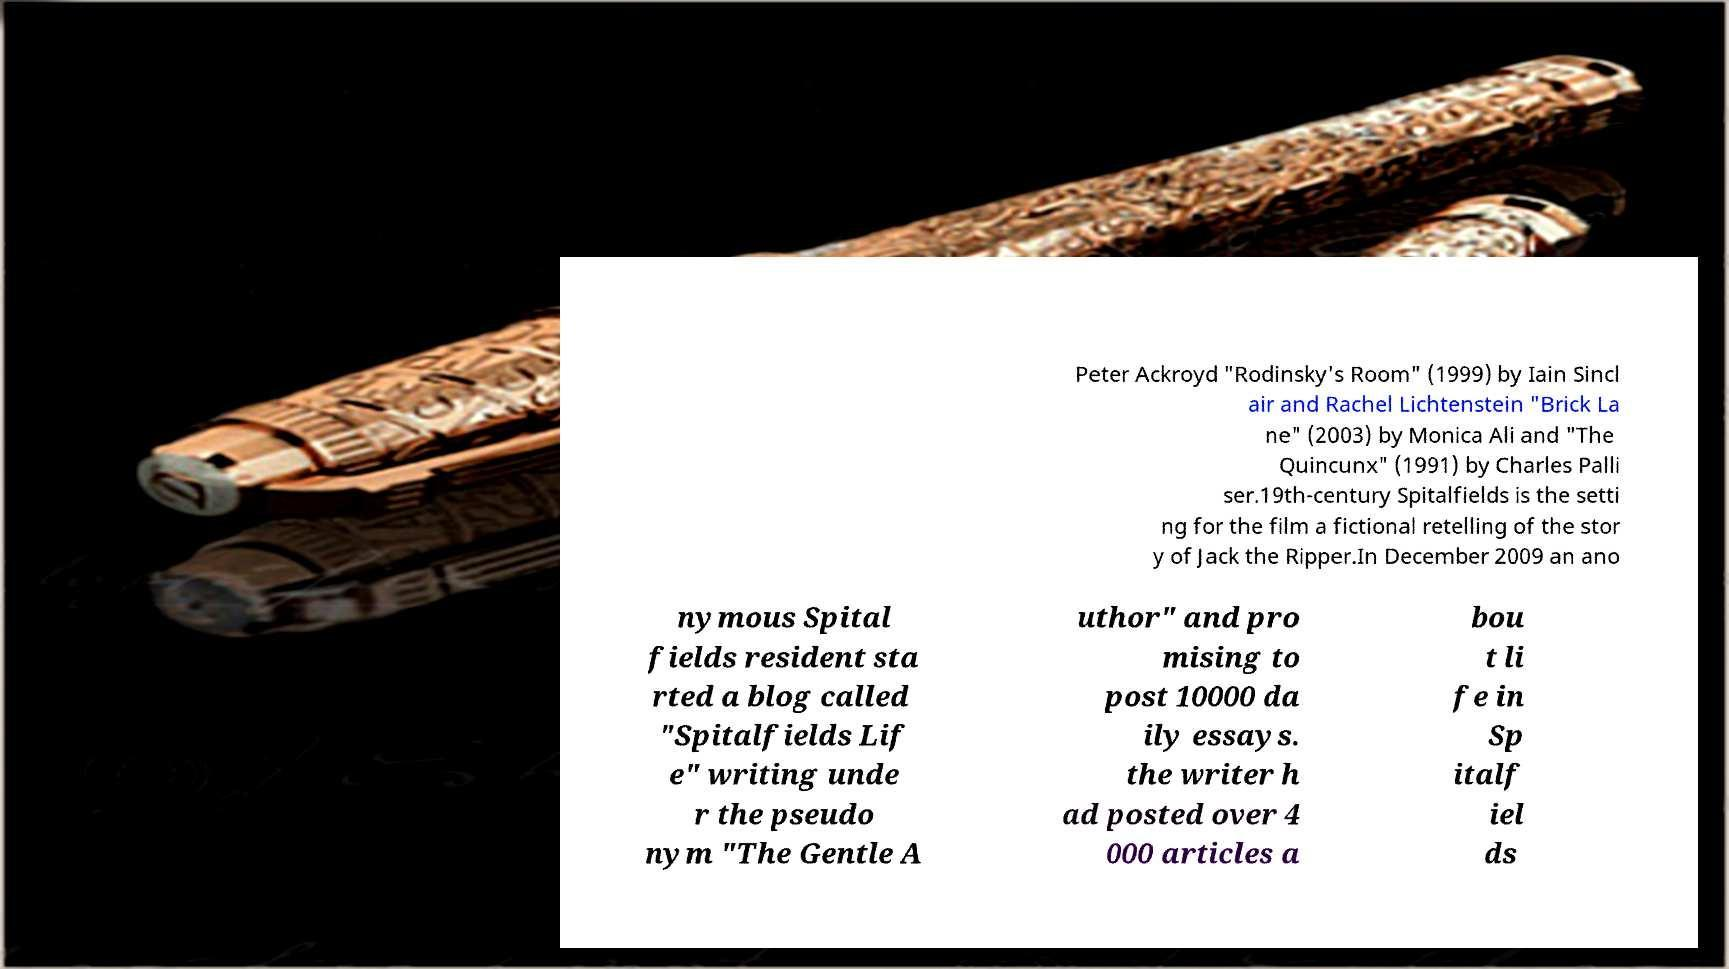Could you extract and type out the text from this image? Peter Ackroyd "Rodinsky's Room" (1999) by Iain Sincl air and Rachel Lichtenstein "Brick La ne" (2003) by Monica Ali and "The Quincunx" (1991) by Charles Palli ser.19th-century Spitalfields is the setti ng for the film a fictional retelling of the stor y of Jack the Ripper.In December 2009 an ano nymous Spital fields resident sta rted a blog called "Spitalfields Lif e" writing unde r the pseudo nym "The Gentle A uthor" and pro mising to post 10000 da ily essays. the writer h ad posted over 4 000 articles a bou t li fe in Sp italf iel ds 